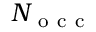<formula> <loc_0><loc_0><loc_500><loc_500>N _ { o c c }</formula> 